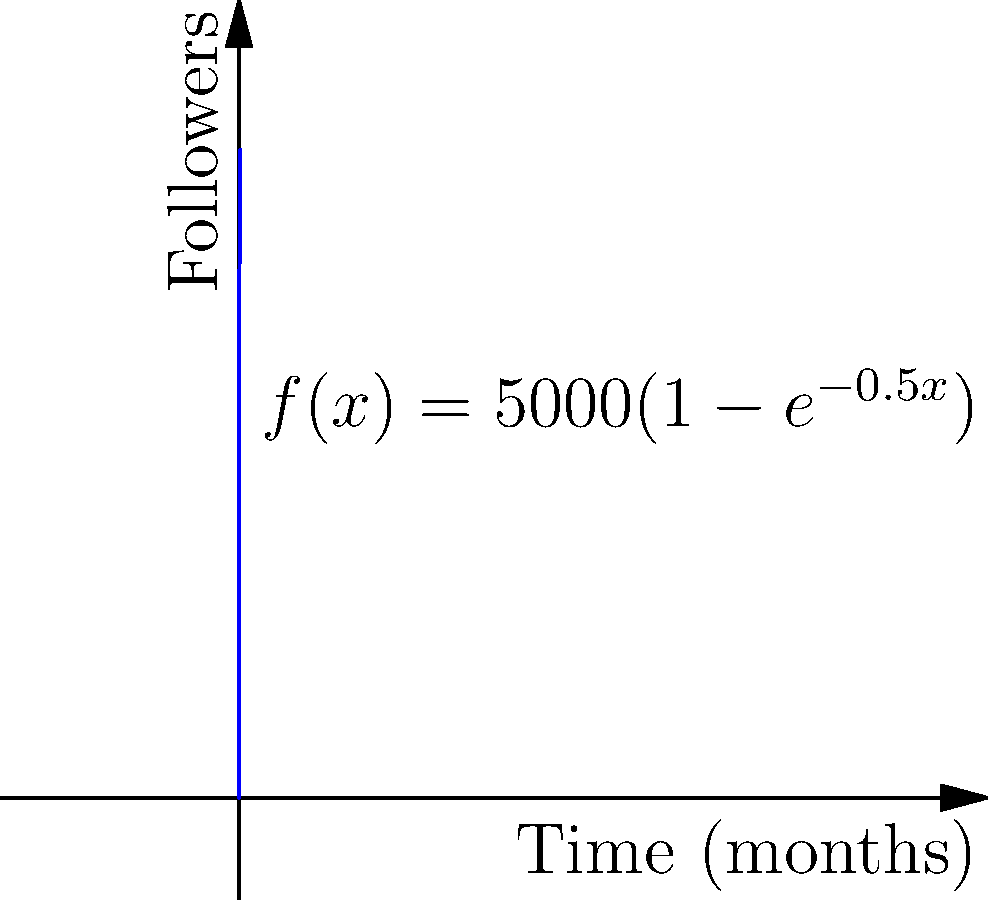Your social media follower growth over time can be modeled by the function $f(x) = 5000(1-e^{-0.5x})$, where $x$ is the time in months and $f(x)$ is the number of followers. Calculate the total area under this curve from 0 to 6 months. This represents the cumulative follower-months gained during this period. Round your answer to the nearest whole number. To find the area under the curve, we need to integrate the function from 0 to 6:

$$A = \int_0^6 5000(1-e^{-0.5x}) dx$$

Let's solve this step-by-step:

1) First, let's separate the integral:
   $$A = \int_0^6 5000 dx - \int_0^6 5000e^{-0.5x} dx$$

2) Integrate the first part:
   $$5000x \bigg|_0^6 = 5000(6) - 5000(0) = 30000$$

3) For the second part, use u-substitution:
   Let $u = -0.5x$, then $du = -0.5dx$ or $dx = -2du$
   When $x = 0$, $u = 0$; when $x = 6$, $u = -3$

   $$-10000 \int_0^{-3} e^u du = -10000[e^u]_0^{-3} = -10000(e^{-3} - 1)$$

4) Combine the results:
   $$A = 30000 - (-10000(e^{-3} - 1))$$
   $$A = 30000 + 10000(e^{-3} - 1)$$
   $$A = 30000 + 10000e^{-3} - 10000$$
   $$A = 20000 + 10000e^{-3}$$

5) Calculate the value (using a calculator):
   $$A ≈ 20000 + 10000(0.0497871) ≈ 20497.871$$

6) Rounding to the nearest whole number:
   $$A ≈ 20498$$
Answer: 20498 follower-months 